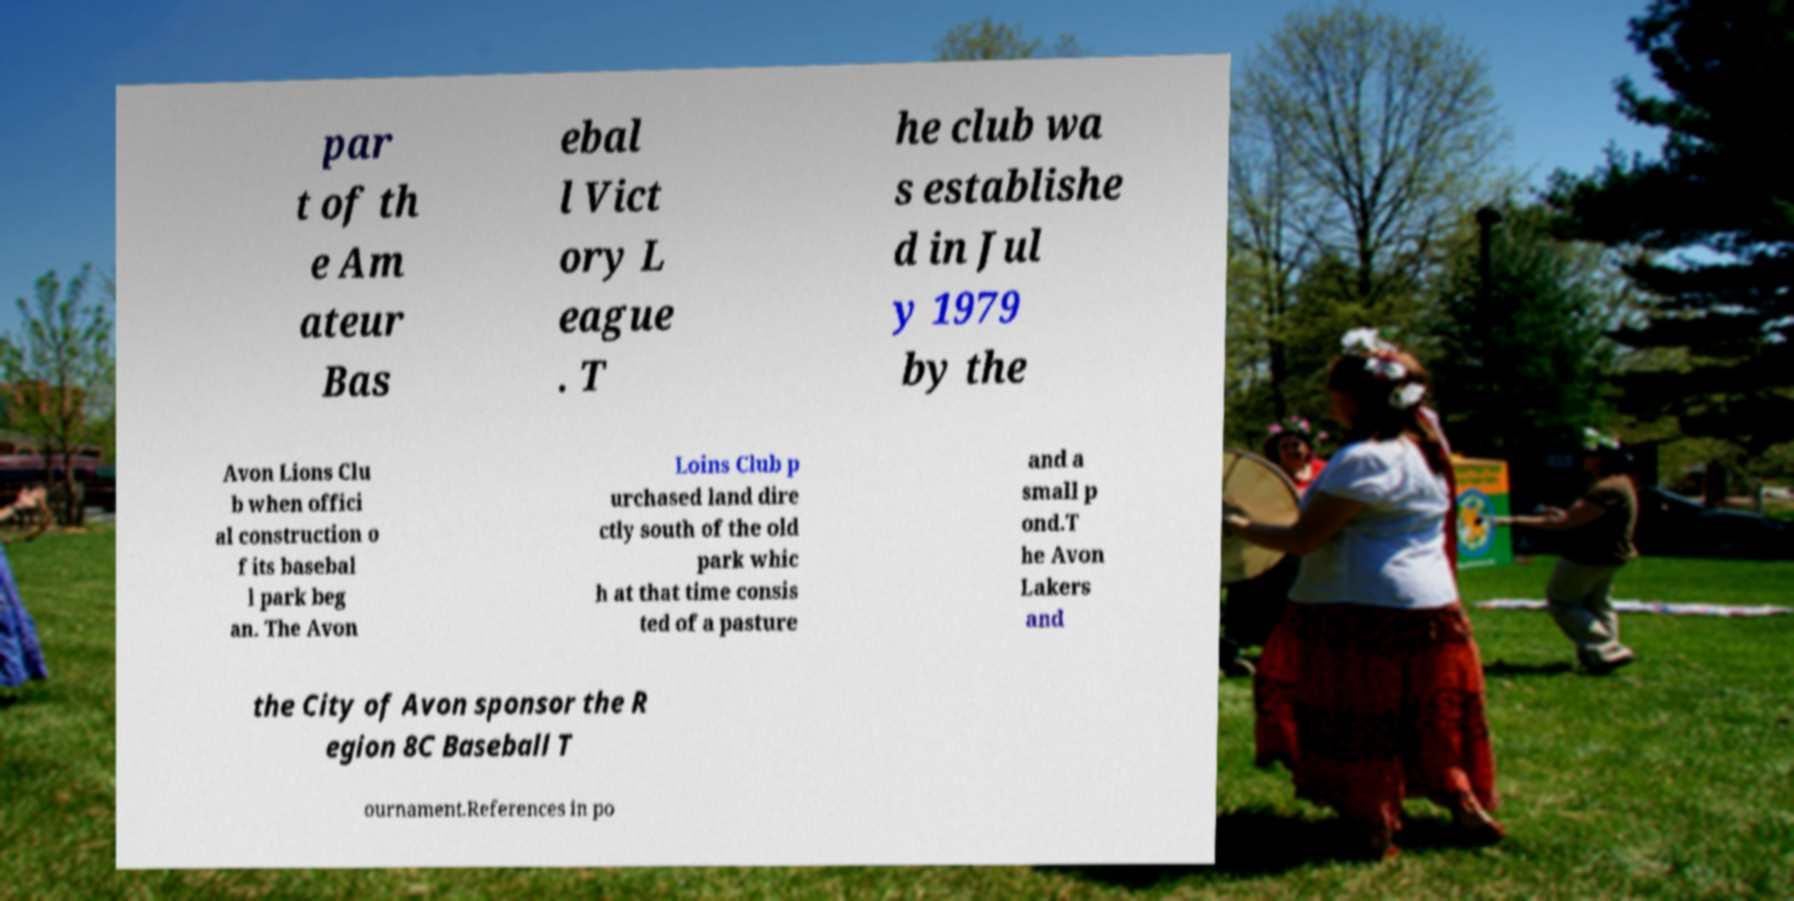Can you accurately transcribe the text from the provided image for me? par t of th e Am ateur Bas ebal l Vict ory L eague . T he club wa s establishe d in Jul y 1979 by the Avon Lions Clu b when offici al construction o f its basebal l park beg an. The Avon Loins Club p urchased land dire ctly south of the old park whic h at that time consis ted of a pasture and a small p ond.T he Avon Lakers and the City of Avon sponsor the R egion 8C Baseball T ournament.References in po 